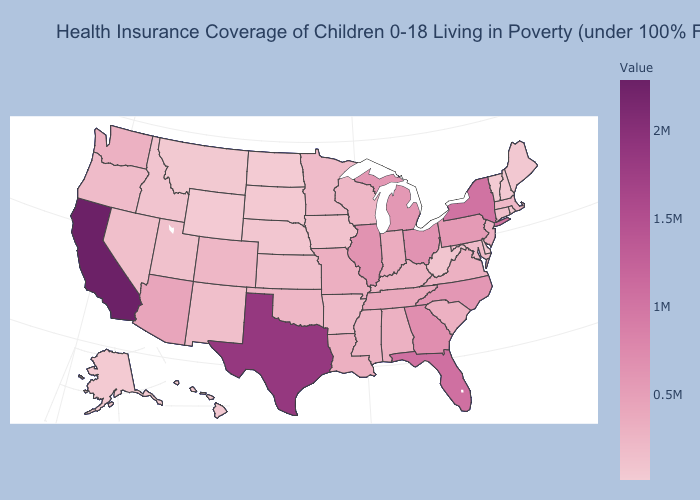Among the states that border Arkansas , does Mississippi have the lowest value?
Short answer required. No. Does California have the highest value in the West?
Answer briefly. Yes. Among the states that border Montana , does South Dakota have the lowest value?
Concise answer only. No. Among the states that border California , which have the lowest value?
Short answer required. Nevada. Does Connecticut have the highest value in the USA?
Write a very short answer. No. Is the legend a continuous bar?
Concise answer only. Yes. Among the states that border Wyoming , does Colorado have the highest value?
Quick response, please. Yes. Is the legend a continuous bar?
Keep it brief. Yes. Does Connecticut have the highest value in the USA?
Concise answer only. No. 